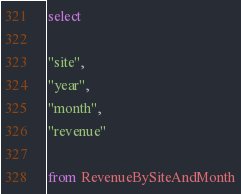Convert code to text. <code><loc_0><loc_0><loc_500><loc_500><_SQL_>select

"site",
"year",
"month",
"revenue"

from RevenueBySiteAndMonth</code> 